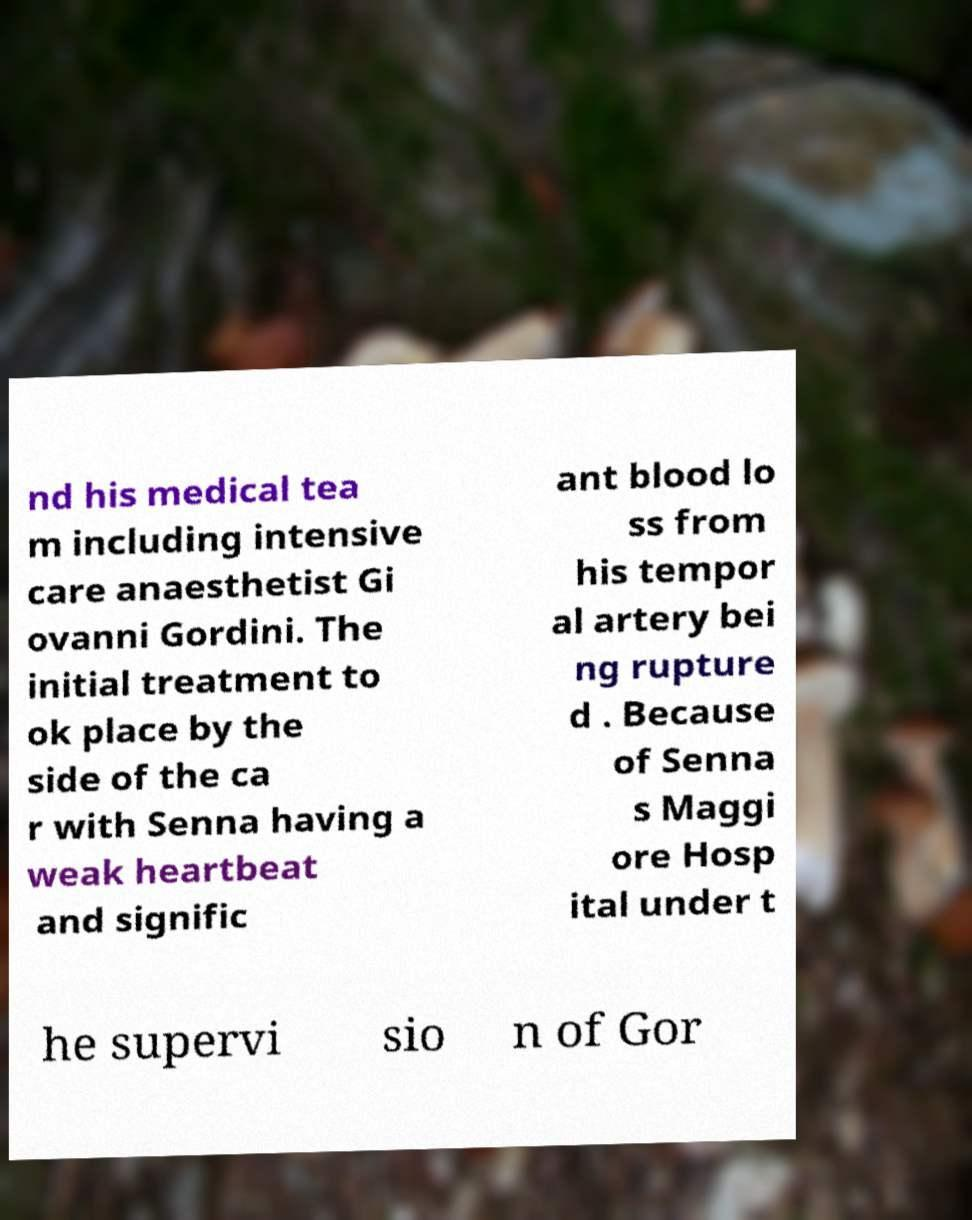Can you accurately transcribe the text from the provided image for me? nd his medical tea m including intensive care anaesthetist Gi ovanni Gordini. The initial treatment to ok place by the side of the ca r with Senna having a weak heartbeat and signific ant blood lo ss from his tempor al artery bei ng rupture d . Because of Senna s Maggi ore Hosp ital under t he supervi sio n of Gor 